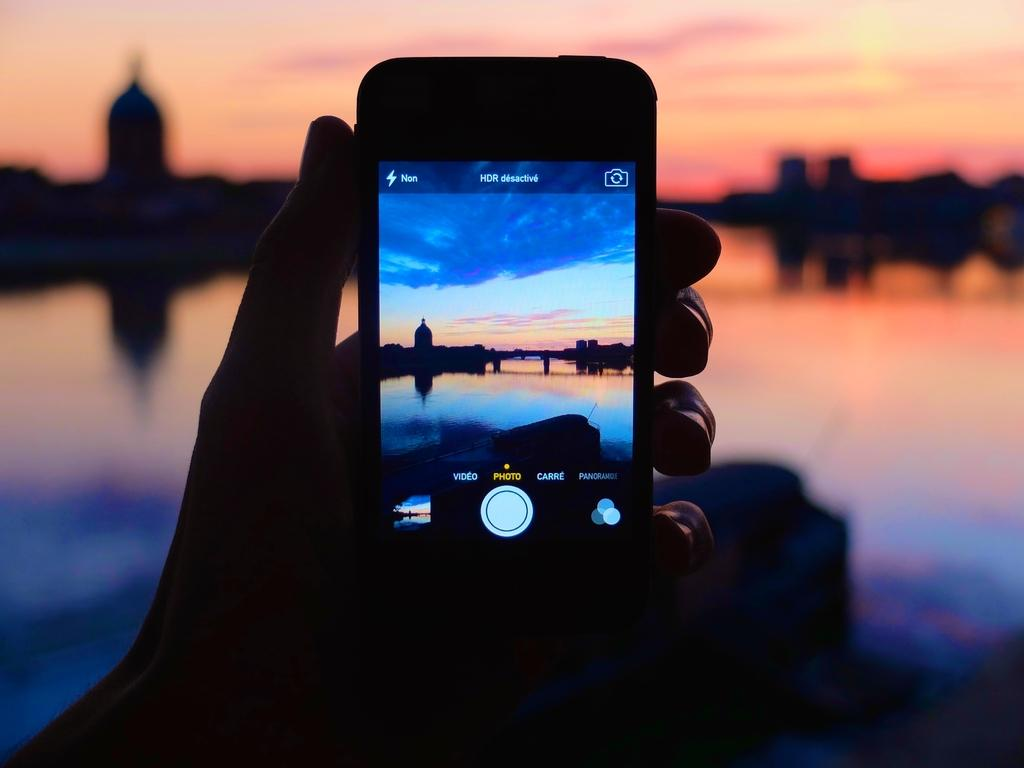<image>
Provide a brief description of the given image. Someone is holding their phone with it set to photo mode, not video or carre. 